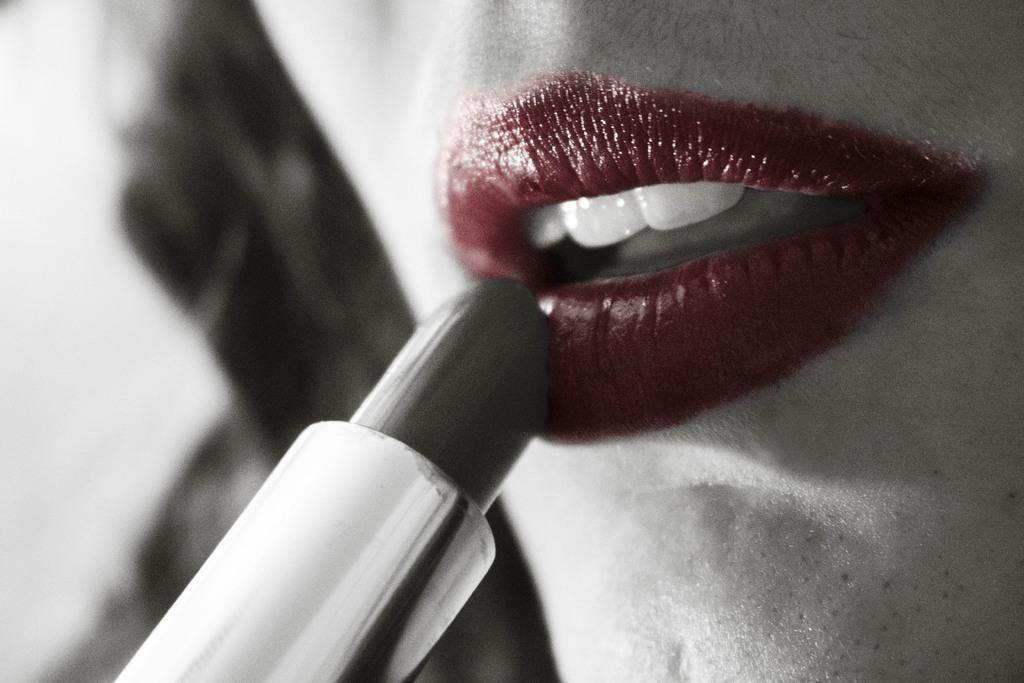Could you give a brief overview of what you see in this image? In the foreground of this picture, there is a lipstick on the left bottom side of the image. On the right side, we can see a red lip of a woman and the hair of her. 